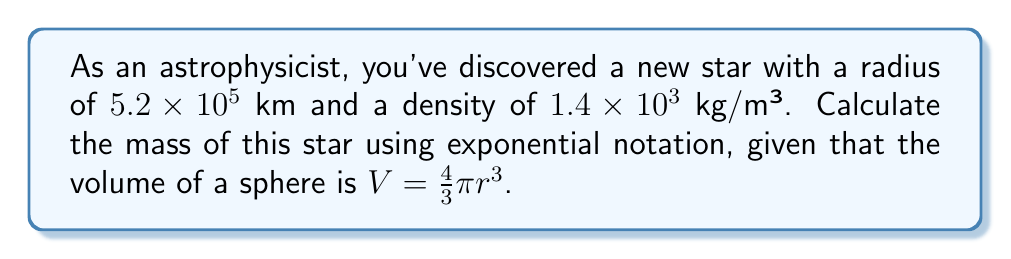Provide a solution to this math problem. Let's approach this step-by-step:

1) First, we need to convert the radius from km to m:
   $5.2 \times 10^5$ km = $5.2 \times 10^8$ m

2) Now, let's calculate the volume of the star using the given formula:
   $V = \frac{4}{3}\pi r^3$
   $V = \frac{4}{3}\pi (5.2 \times 10^8)^3$
   $V = \frac{4}{3}\pi (1.4048 \times 10^{26})$
   $V \approx 5.8843 \times 10^{26}$ m³

3) We know that mass = density × volume. Let's plug in our values:
   $m = \rho V$
   $m = (1.4 \times 10^3$ kg/m³$)(5.8843 \times 10^{26}$ m³$)$

4) Now, let's multiply these numbers:
   $m = 8.238 \times 10^{29}$ kg

5) To express this in scientific notation with 3 significant figures:
   $m = 8.24 \times 10^{29}$ kg
Answer: $8.24 \times 10^{29}$ kg 